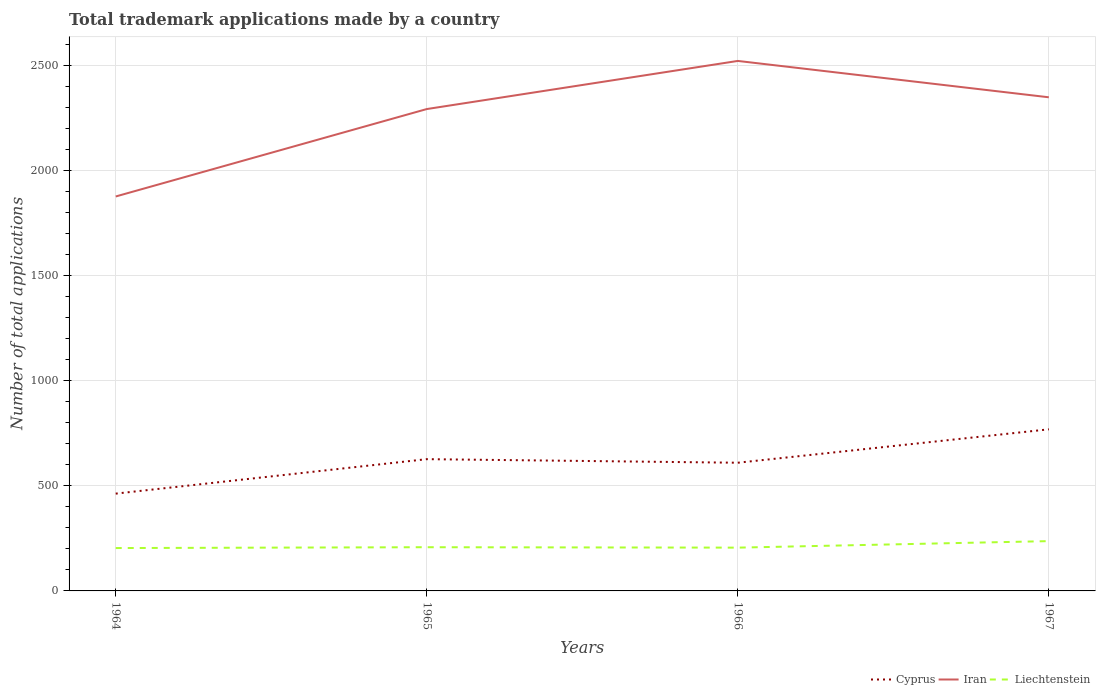Does the line corresponding to Cyprus intersect with the line corresponding to Liechtenstein?
Your answer should be compact. No. Across all years, what is the maximum number of applications made by in Iran?
Ensure brevity in your answer.  1877. In which year was the number of applications made by in Iran maximum?
Your answer should be very brief. 1964. What is the difference between the highest and the second highest number of applications made by in Cyprus?
Provide a succinct answer. 306. What is the difference between the highest and the lowest number of applications made by in Cyprus?
Offer a terse response. 2. Is the number of applications made by in Liechtenstein strictly greater than the number of applications made by in Cyprus over the years?
Ensure brevity in your answer.  Yes. Does the graph contain any zero values?
Make the answer very short. No. Does the graph contain grids?
Your response must be concise. Yes. How many legend labels are there?
Provide a short and direct response. 3. How are the legend labels stacked?
Offer a terse response. Horizontal. What is the title of the graph?
Offer a terse response. Total trademark applications made by a country. Does "Trinidad and Tobago" appear as one of the legend labels in the graph?
Ensure brevity in your answer.  No. What is the label or title of the X-axis?
Ensure brevity in your answer.  Years. What is the label or title of the Y-axis?
Offer a very short reply. Number of total applications. What is the Number of total applications in Cyprus in 1964?
Offer a very short reply. 463. What is the Number of total applications in Iran in 1964?
Provide a succinct answer. 1877. What is the Number of total applications in Liechtenstein in 1964?
Offer a very short reply. 204. What is the Number of total applications of Cyprus in 1965?
Your answer should be very brief. 627. What is the Number of total applications in Iran in 1965?
Make the answer very short. 2293. What is the Number of total applications in Liechtenstein in 1965?
Ensure brevity in your answer.  208. What is the Number of total applications of Cyprus in 1966?
Your answer should be compact. 610. What is the Number of total applications of Iran in 1966?
Keep it short and to the point. 2522. What is the Number of total applications in Liechtenstein in 1966?
Ensure brevity in your answer.  206. What is the Number of total applications of Cyprus in 1967?
Provide a short and direct response. 769. What is the Number of total applications in Iran in 1967?
Make the answer very short. 2349. What is the Number of total applications in Liechtenstein in 1967?
Your answer should be very brief. 237. Across all years, what is the maximum Number of total applications in Cyprus?
Offer a very short reply. 769. Across all years, what is the maximum Number of total applications of Iran?
Offer a very short reply. 2522. Across all years, what is the maximum Number of total applications in Liechtenstein?
Provide a short and direct response. 237. Across all years, what is the minimum Number of total applications of Cyprus?
Make the answer very short. 463. Across all years, what is the minimum Number of total applications of Iran?
Offer a terse response. 1877. Across all years, what is the minimum Number of total applications in Liechtenstein?
Offer a very short reply. 204. What is the total Number of total applications of Cyprus in the graph?
Give a very brief answer. 2469. What is the total Number of total applications in Iran in the graph?
Your answer should be very brief. 9041. What is the total Number of total applications of Liechtenstein in the graph?
Make the answer very short. 855. What is the difference between the Number of total applications of Cyprus in 1964 and that in 1965?
Ensure brevity in your answer.  -164. What is the difference between the Number of total applications of Iran in 1964 and that in 1965?
Provide a short and direct response. -416. What is the difference between the Number of total applications of Cyprus in 1964 and that in 1966?
Your response must be concise. -147. What is the difference between the Number of total applications in Iran in 1964 and that in 1966?
Make the answer very short. -645. What is the difference between the Number of total applications in Liechtenstein in 1964 and that in 1966?
Keep it short and to the point. -2. What is the difference between the Number of total applications of Cyprus in 1964 and that in 1967?
Your answer should be very brief. -306. What is the difference between the Number of total applications in Iran in 1964 and that in 1967?
Offer a terse response. -472. What is the difference between the Number of total applications of Liechtenstein in 1964 and that in 1967?
Offer a very short reply. -33. What is the difference between the Number of total applications in Cyprus in 1965 and that in 1966?
Your answer should be very brief. 17. What is the difference between the Number of total applications in Iran in 1965 and that in 1966?
Your answer should be compact. -229. What is the difference between the Number of total applications of Cyprus in 1965 and that in 1967?
Provide a succinct answer. -142. What is the difference between the Number of total applications of Iran in 1965 and that in 1967?
Your answer should be compact. -56. What is the difference between the Number of total applications of Cyprus in 1966 and that in 1967?
Ensure brevity in your answer.  -159. What is the difference between the Number of total applications of Iran in 1966 and that in 1967?
Provide a short and direct response. 173. What is the difference between the Number of total applications in Liechtenstein in 1966 and that in 1967?
Give a very brief answer. -31. What is the difference between the Number of total applications in Cyprus in 1964 and the Number of total applications in Iran in 1965?
Keep it short and to the point. -1830. What is the difference between the Number of total applications of Cyprus in 1964 and the Number of total applications of Liechtenstein in 1965?
Give a very brief answer. 255. What is the difference between the Number of total applications in Iran in 1964 and the Number of total applications in Liechtenstein in 1965?
Offer a terse response. 1669. What is the difference between the Number of total applications of Cyprus in 1964 and the Number of total applications of Iran in 1966?
Offer a terse response. -2059. What is the difference between the Number of total applications in Cyprus in 1964 and the Number of total applications in Liechtenstein in 1966?
Offer a terse response. 257. What is the difference between the Number of total applications of Iran in 1964 and the Number of total applications of Liechtenstein in 1966?
Give a very brief answer. 1671. What is the difference between the Number of total applications in Cyprus in 1964 and the Number of total applications in Iran in 1967?
Your answer should be very brief. -1886. What is the difference between the Number of total applications of Cyprus in 1964 and the Number of total applications of Liechtenstein in 1967?
Your answer should be compact. 226. What is the difference between the Number of total applications of Iran in 1964 and the Number of total applications of Liechtenstein in 1967?
Your answer should be compact. 1640. What is the difference between the Number of total applications in Cyprus in 1965 and the Number of total applications in Iran in 1966?
Your answer should be very brief. -1895. What is the difference between the Number of total applications of Cyprus in 1965 and the Number of total applications of Liechtenstein in 1966?
Your answer should be compact. 421. What is the difference between the Number of total applications of Iran in 1965 and the Number of total applications of Liechtenstein in 1966?
Offer a terse response. 2087. What is the difference between the Number of total applications in Cyprus in 1965 and the Number of total applications in Iran in 1967?
Make the answer very short. -1722. What is the difference between the Number of total applications in Cyprus in 1965 and the Number of total applications in Liechtenstein in 1967?
Make the answer very short. 390. What is the difference between the Number of total applications in Iran in 1965 and the Number of total applications in Liechtenstein in 1967?
Offer a terse response. 2056. What is the difference between the Number of total applications in Cyprus in 1966 and the Number of total applications in Iran in 1967?
Keep it short and to the point. -1739. What is the difference between the Number of total applications in Cyprus in 1966 and the Number of total applications in Liechtenstein in 1967?
Keep it short and to the point. 373. What is the difference between the Number of total applications in Iran in 1966 and the Number of total applications in Liechtenstein in 1967?
Provide a short and direct response. 2285. What is the average Number of total applications of Cyprus per year?
Keep it short and to the point. 617.25. What is the average Number of total applications of Iran per year?
Your answer should be very brief. 2260.25. What is the average Number of total applications of Liechtenstein per year?
Your answer should be compact. 213.75. In the year 1964, what is the difference between the Number of total applications of Cyprus and Number of total applications of Iran?
Your answer should be compact. -1414. In the year 1964, what is the difference between the Number of total applications in Cyprus and Number of total applications in Liechtenstein?
Your answer should be compact. 259. In the year 1964, what is the difference between the Number of total applications in Iran and Number of total applications in Liechtenstein?
Give a very brief answer. 1673. In the year 1965, what is the difference between the Number of total applications of Cyprus and Number of total applications of Iran?
Provide a short and direct response. -1666. In the year 1965, what is the difference between the Number of total applications of Cyprus and Number of total applications of Liechtenstein?
Your answer should be very brief. 419. In the year 1965, what is the difference between the Number of total applications in Iran and Number of total applications in Liechtenstein?
Provide a short and direct response. 2085. In the year 1966, what is the difference between the Number of total applications of Cyprus and Number of total applications of Iran?
Your response must be concise. -1912. In the year 1966, what is the difference between the Number of total applications in Cyprus and Number of total applications in Liechtenstein?
Provide a short and direct response. 404. In the year 1966, what is the difference between the Number of total applications in Iran and Number of total applications in Liechtenstein?
Ensure brevity in your answer.  2316. In the year 1967, what is the difference between the Number of total applications in Cyprus and Number of total applications in Iran?
Provide a succinct answer. -1580. In the year 1967, what is the difference between the Number of total applications of Cyprus and Number of total applications of Liechtenstein?
Provide a short and direct response. 532. In the year 1967, what is the difference between the Number of total applications of Iran and Number of total applications of Liechtenstein?
Offer a very short reply. 2112. What is the ratio of the Number of total applications in Cyprus in 1964 to that in 1965?
Your answer should be very brief. 0.74. What is the ratio of the Number of total applications in Iran in 1964 to that in 1965?
Your answer should be compact. 0.82. What is the ratio of the Number of total applications in Liechtenstein in 1964 to that in 1965?
Your answer should be very brief. 0.98. What is the ratio of the Number of total applications of Cyprus in 1964 to that in 1966?
Your response must be concise. 0.76. What is the ratio of the Number of total applications of Iran in 1964 to that in 1966?
Your response must be concise. 0.74. What is the ratio of the Number of total applications of Liechtenstein in 1964 to that in 1966?
Your response must be concise. 0.99. What is the ratio of the Number of total applications in Cyprus in 1964 to that in 1967?
Make the answer very short. 0.6. What is the ratio of the Number of total applications in Iran in 1964 to that in 1967?
Provide a succinct answer. 0.8. What is the ratio of the Number of total applications of Liechtenstein in 1964 to that in 1967?
Provide a succinct answer. 0.86. What is the ratio of the Number of total applications in Cyprus in 1965 to that in 1966?
Your response must be concise. 1.03. What is the ratio of the Number of total applications of Iran in 1965 to that in 1966?
Keep it short and to the point. 0.91. What is the ratio of the Number of total applications of Liechtenstein in 1965 to that in 1966?
Give a very brief answer. 1.01. What is the ratio of the Number of total applications in Cyprus in 1965 to that in 1967?
Your response must be concise. 0.82. What is the ratio of the Number of total applications of Iran in 1965 to that in 1967?
Give a very brief answer. 0.98. What is the ratio of the Number of total applications in Liechtenstein in 1965 to that in 1967?
Ensure brevity in your answer.  0.88. What is the ratio of the Number of total applications in Cyprus in 1966 to that in 1967?
Make the answer very short. 0.79. What is the ratio of the Number of total applications in Iran in 1966 to that in 1967?
Your answer should be very brief. 1.07. What is the ratio of the Number of total applications in Liechtenstein in 1966 to that in 1967?
Give a very brief answer. 0.87. What is the difference between the highest and the second highest Number of total applications of Cyprus?
Your answer should be very brief. 142. What is the difference between the highest and the second highest Number of total applications of Iran?
Your answer should be compact. 173. What is the difference between the highest and the second highest Number of total applications of Liechtenstein?
Give a very brief answer. 29. What is the difference between the highest and the lowest Number of total applications of Cyprus?
Ensure brevity in your answer.  306. What is the difference between the highest and the lowest Number of total applications in Iran?
Give a very brief answer. 645. 